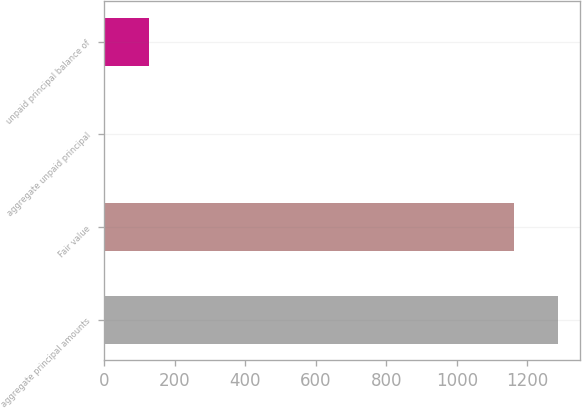Convert chart. <chart><loc_0><loc_0><loc_500><loc_500><bar_chart><fcel>aggregate principal amounts<fcel>Fair value<fcel>aggregate unpaid principal<fcel>unpaid principal balance of<nl><fcel>1286.3<fcel>1162<fcel>2<fcel>126.3<nl></chart> 